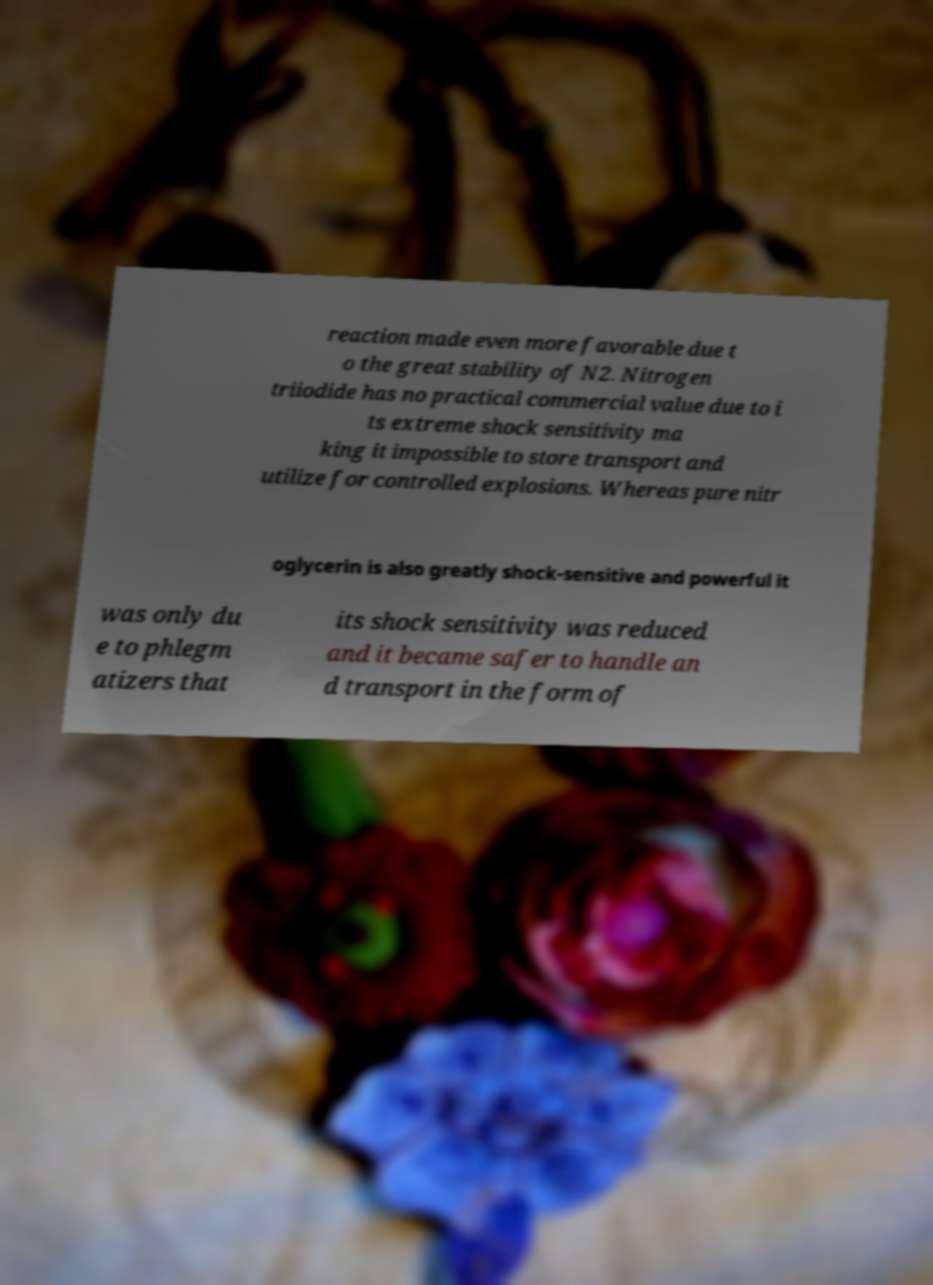Could you assist in decoding the text presented in this image and type it out clearly? reaction made even more favorable due t o the great stability of N2. Nitrogen triiodide has no practical commercial value due to i ts extreme shock sensitivity ma king it impossible to store transport and utilize for controlled explosions. Whereas pure nitr oglycerin is also greatly shock-sensitive and powerful it was only du e to phlegm atizers that its shock sensitivity was reduced and it became safer to handle an d transport in the form of 